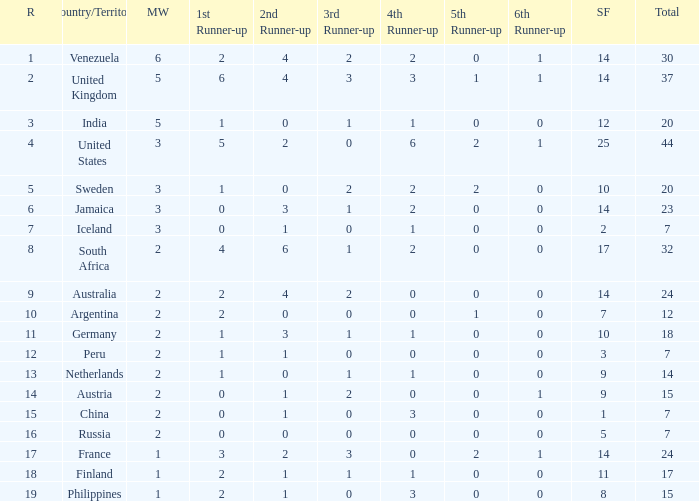Which countries have a 5th runner-up ranking is 2 and the 3rd runner-up ranking is 0 44.0. 